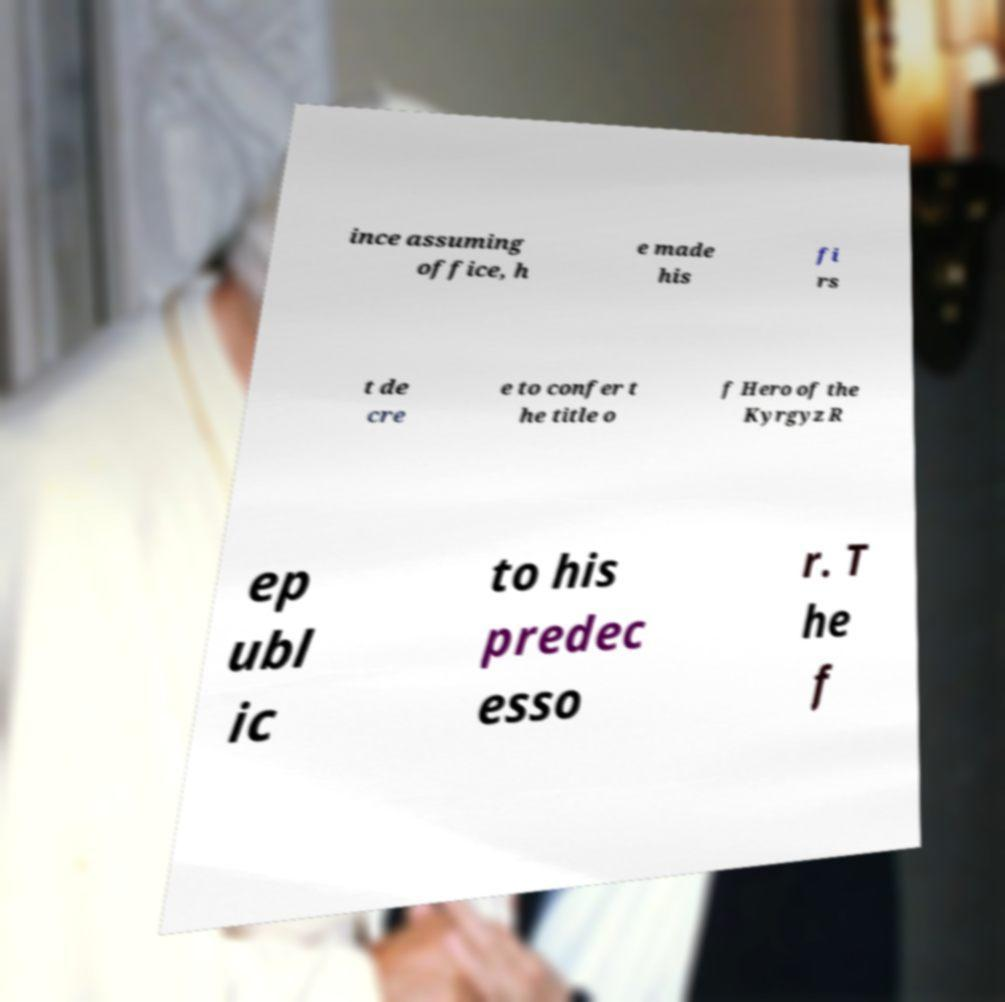Could you assist in decoding the text presented in this image and type it out clearly? ince assuming office, h e made his fi rs t de cre e to confer t he title o f Hero of the Kyrgyz R ep ubl ic to his predec esso r. T he f 